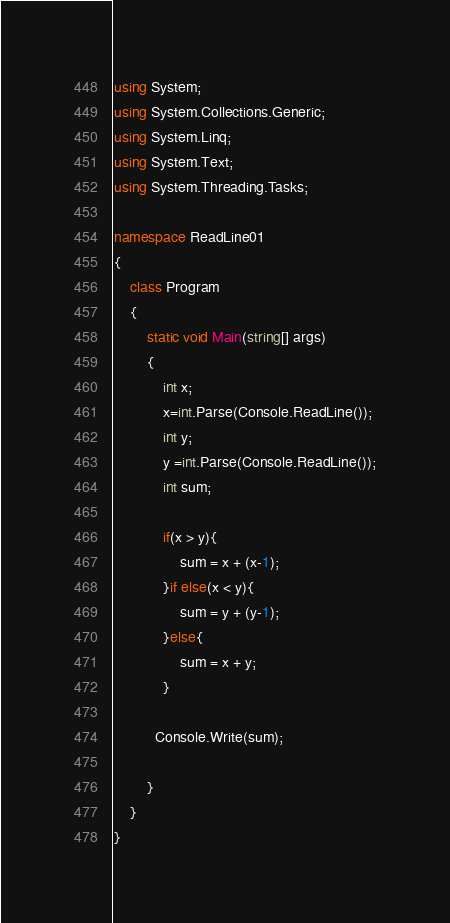<code> <loc_0><loc_0><loc_500><loc_500><_C#_>using System;
using System.Collections.Generic;
using System.Linq;
using System.Text;
using System.Threading.Tasks;
 
namespace ReadLine01
{
    class Program
    {
        static void Main(string[] args)
        {
            int x;
            x=int.Parse(Console.ReadLine());
            int y;
            y =int.Parse(Console.ReadLine());
			int sum;
          
			if(x > y){
				sum = x + (x-1);
            }if else(x < y){
              	sum = y + (y-1);
            }else{
                sum = x + y;
            }
 
          Console.Write(sum);
 
        }
    }
}</code> 